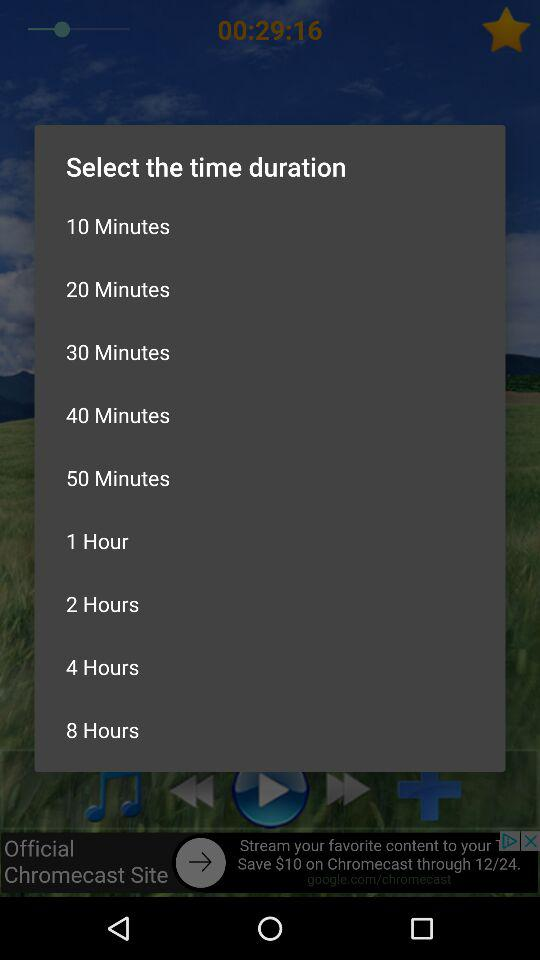How many minutes are there between the 40 and 50 minute time durations?
Answer the question using a single word or phrase. 10 